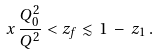Convert formula to latex. <formula><loc_0><loc_0><loc_500><loc_500>x \, \frac { Q _ { 0 } ^ { 2 } } { Q ^ { 2 } } < z _ { f } \lesssim 1 \, - \, z _ { 1 } \, .</formula> 